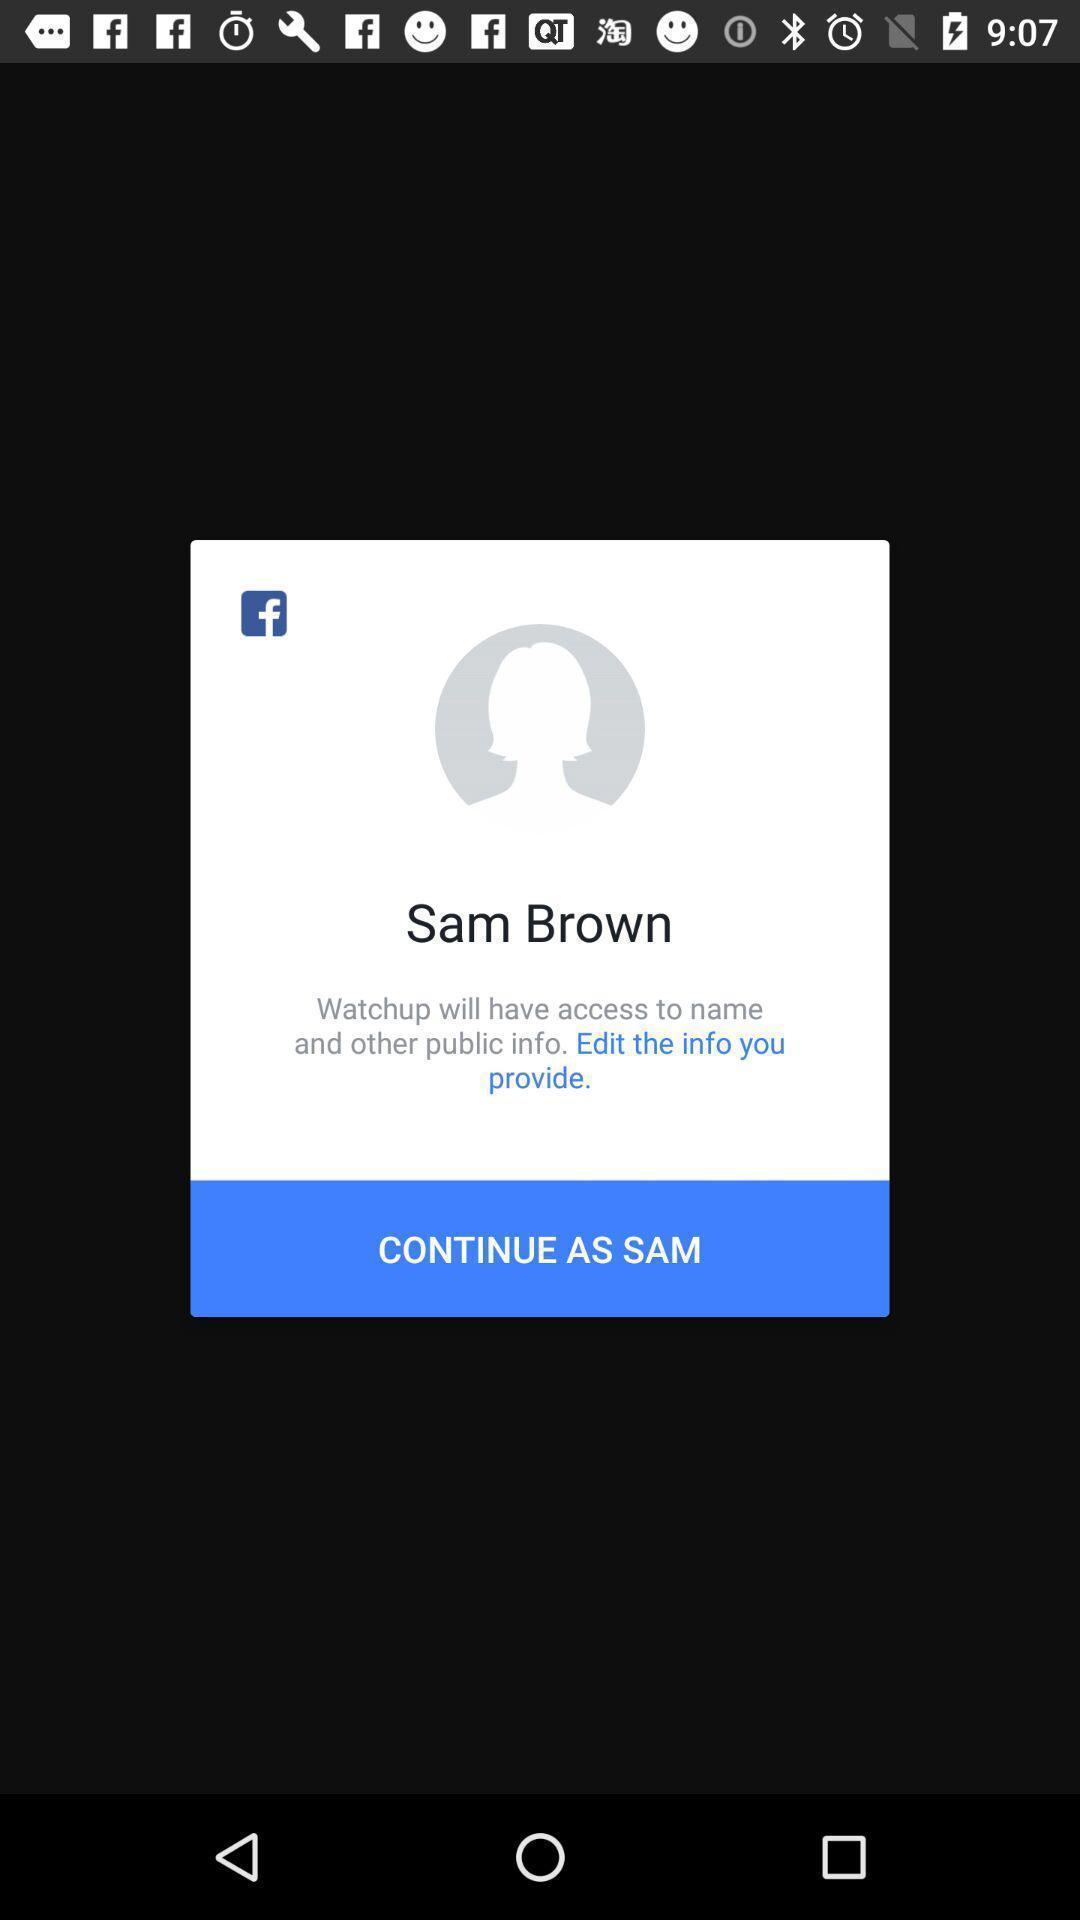What details can you identify in this image? Screen displaying the profile in a social app. 